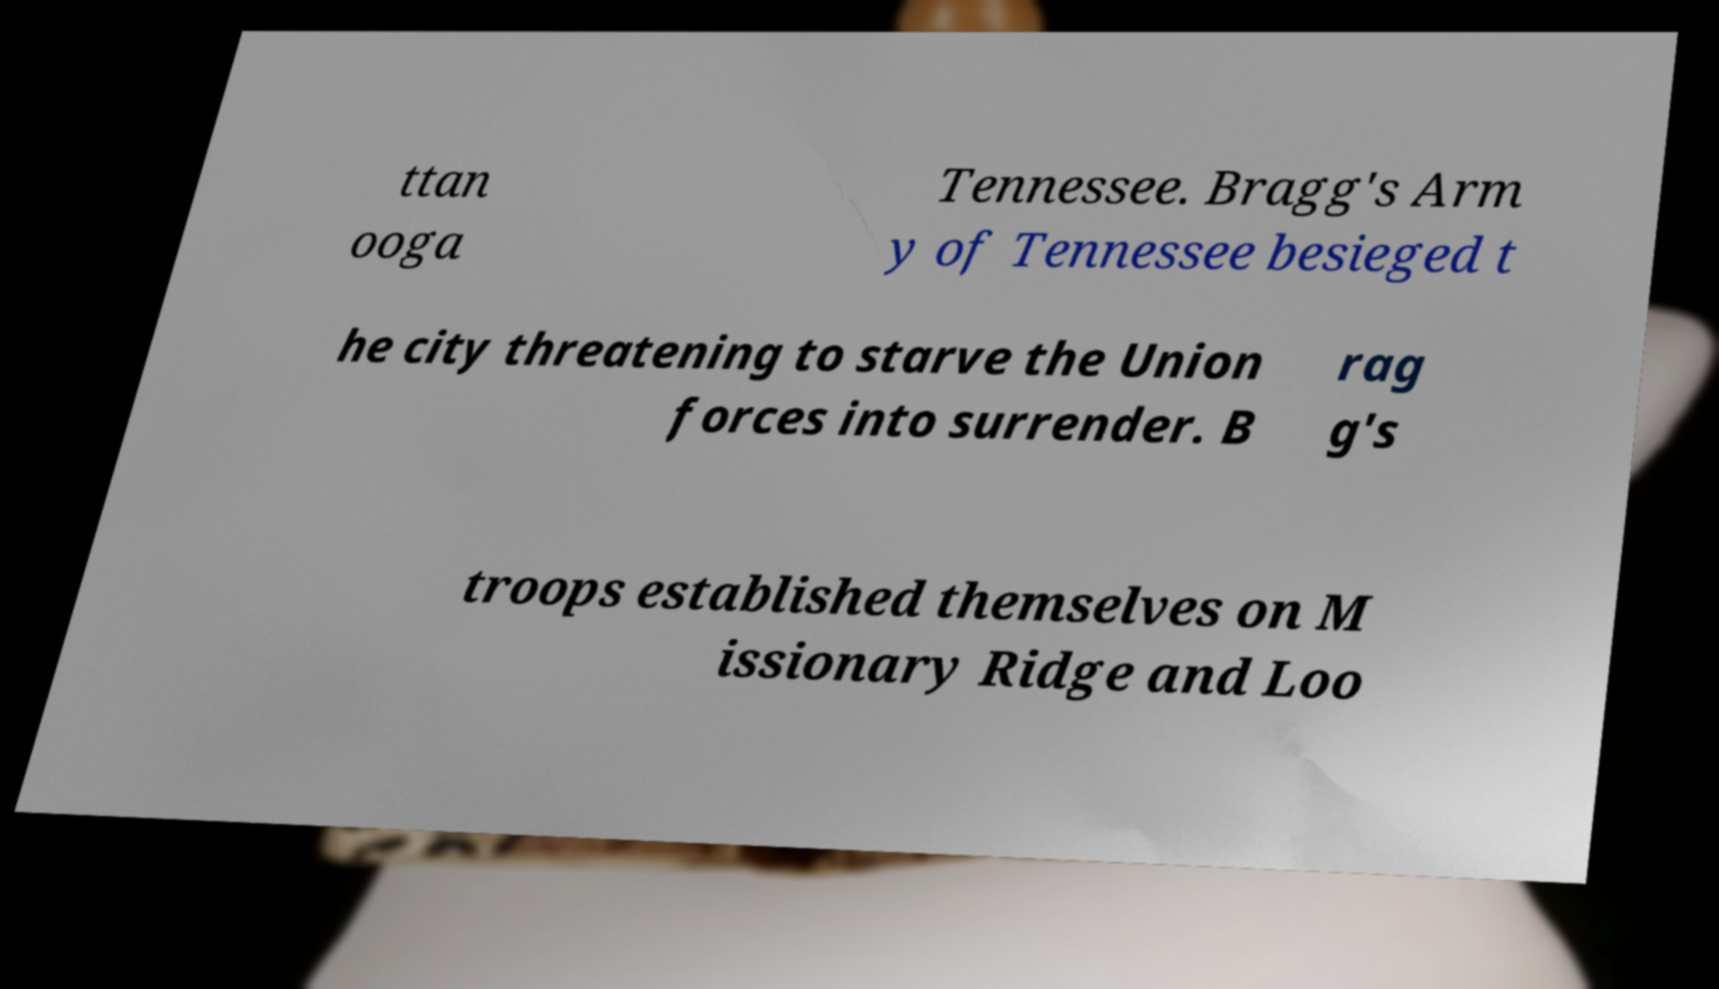Please read and relay the text visible in this image. What does it say? ttan ooga Tennessee. Bragg's Arm y of Tennessee besieged t he city threatening to starve the Union forces into surrender. B rag g's troops established themselves on M issionary Ridge and Loo 